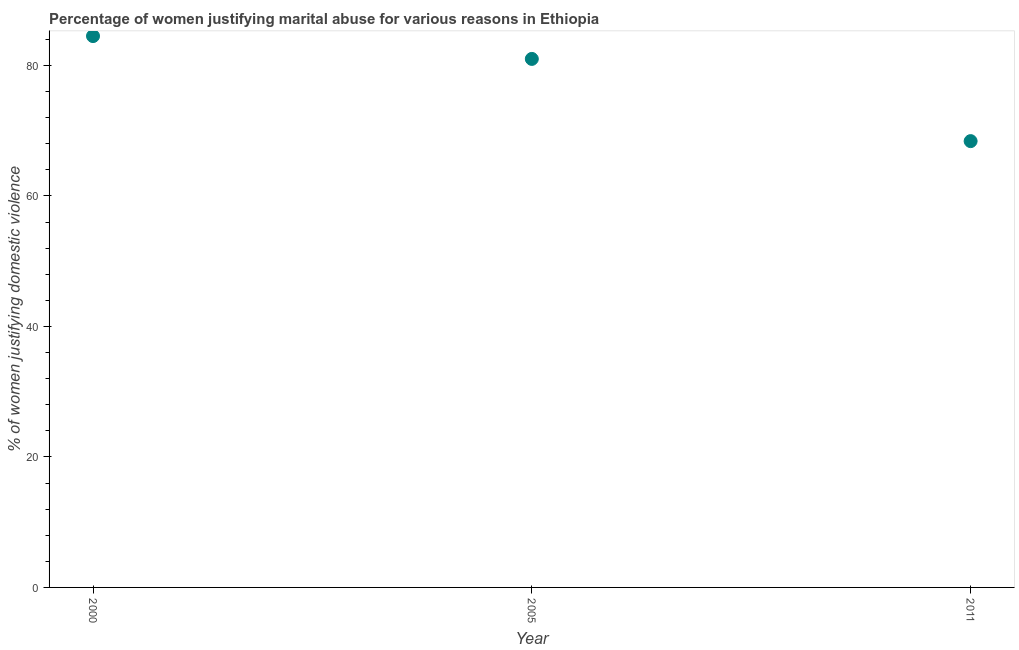What is the percentage of women justifying marital abuse in 2011?
Offer a very short reply. 68.4. Across all years, what is the maximum percentage of women justifying marital abuse?
Provide a short and direct response. 84.5. Across all years, what is the minimum percentage of women justifying marital abuse?
Give a very brief answer. 68.4. In which year was the percentage of women justifying marital abuse minimum?
Make the answer very short. 2011. What is the sum of the percentage of women justifying marital abuse?
Your answer should be compact. 233.9. What is the difference between the percentage of women justifying marital abuse in 2005 and 2011?
Provide a short and direct response. 12.6. What is the average percentage of women justifying marital abuse per year?
Offer a terse response. 77.97. Do a majority of the years between 2005 and 2011 (inclusive) have percentage of women justifying marital abuse greater than 48 %?
Your answer should be compact. Yes. What is the ratio of the percentage of women justifying marital abuse in 2005 to that in 2011?
Keep it short and to the point. 1.18. Is the percentage of women justifying marital abuse in 2000 less than that in 2005?
Your answer should be very brief. No. Is the difference between the percentage of women justifying marital abuse in 2000 and 2011 greater than the difference between any two years?
Give a very brief answer. Yes. What is the difference between the highest and the second highest percentage of women justifying marital abuse?
Make the answer very short. 3.5. What is the difference between the highest and the lowest percentage of women justifying marital abuse?
Your answer should be very brief. 16.1. In how many years, is the percentage of women justifying marital abuse greater than the average percentage of women justifying marital abuse taken over all years?
Keep it short and to the point. 2. Does the percentage of women justifying marital abuse monotonically increase over the years?
Offer a terse response. No. How many dotlines are there?
Keep it short and to the point. 1. What is the difference between two consecutive major ticks on the Y-axis?
Make the answer very short. 20. Are the values on the major ticks of Y-axis written in scientific E-notation?
Give a very brief answer. No. Does the graph contain grids?
Your answer should be very brief. No. What is the title of the graph?
Provide a succinct answer. Percentage of women justifying marital abuse for various reasons in Ethiopia. What is the label or title of the Y-axis?
Ensure brevity in your answer.  % of women justifying domestic violence. What is the % of women justifying domestic violence in 2000?
Offer a terse response. 84.5. What is the % of women justifying domestic violence in 2011?
Your response must be concise. 68.4. What is the ratio of the % of women justifying domestic violence in 2000 to that in 2005?
Offer a very short reply. 1.04. What is the ratio of the % of women justifying domestic violence in 2000 to that in 2011?
Provide a succinct answer. 1.24. What is the ratio of the % of women justifying domestic violence in 2005 to that in 2011?
Offer a very short reply. 1.18. 